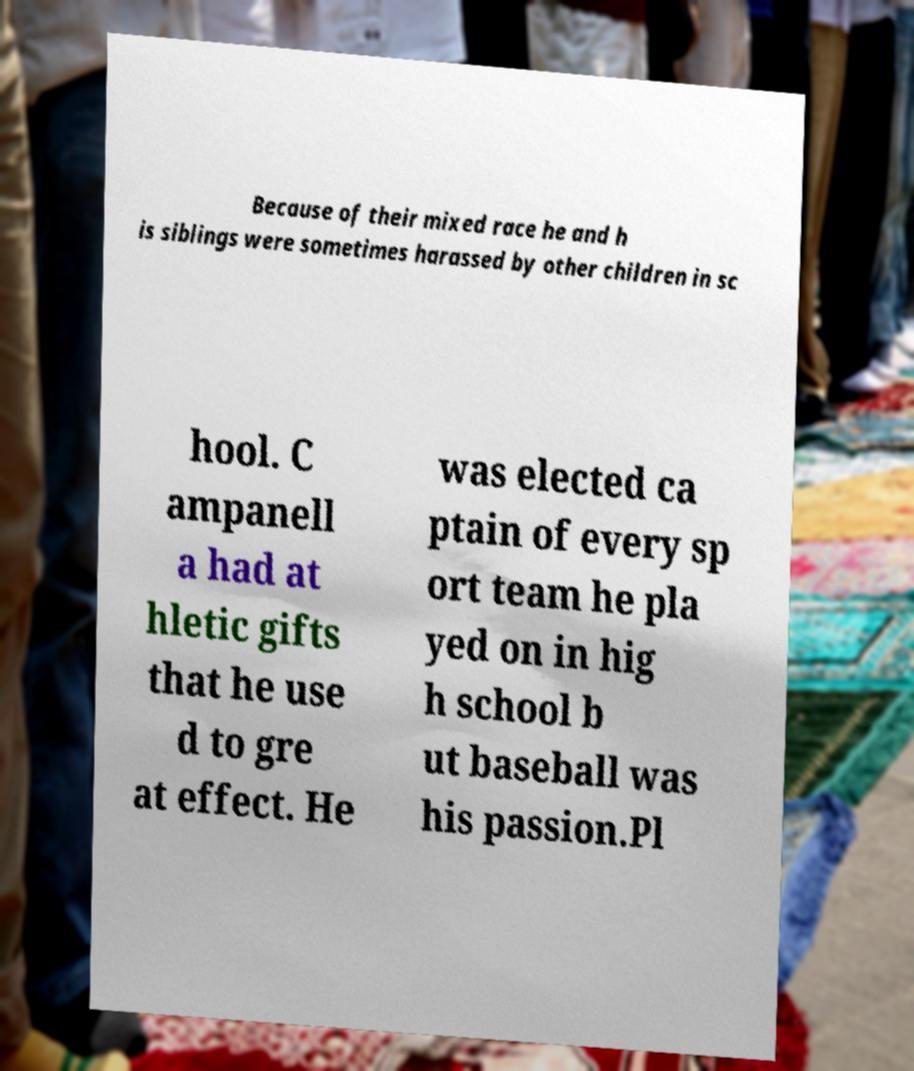For documentation purposes, I need the text within this image transcribed. Could you provide that? Because of their mixed race he and h is siblings were sometimes harassed by other children in sc hool. C ampanell a had at hletic gifts that he use d to gre at effect. He was elected ca ptain of every sp ort team he pla yed on in hig h school b ut baseball was his passion.Pl 